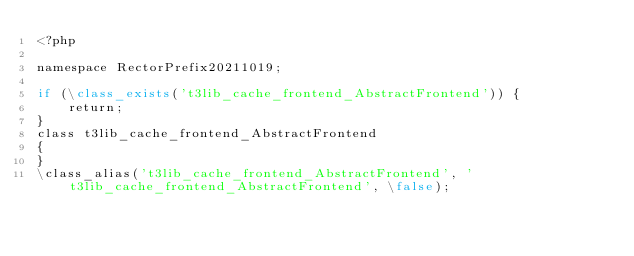<code> <loc_0><loc_0><loc_500><loc_500><_PHP_><?php

namespace RectorPrefix20211019;

if (\class_exists('t3lib_cache_frontend_AbstractFrontend')) {
    return;
}
class t3lib_cache_frontend_AbstractFrontend
{
}
\class_alias('t3lib_cache_frontend_AbstractFrontend', 't3lib_cache_frontend_AbstractFrontend', \false);
</code> 